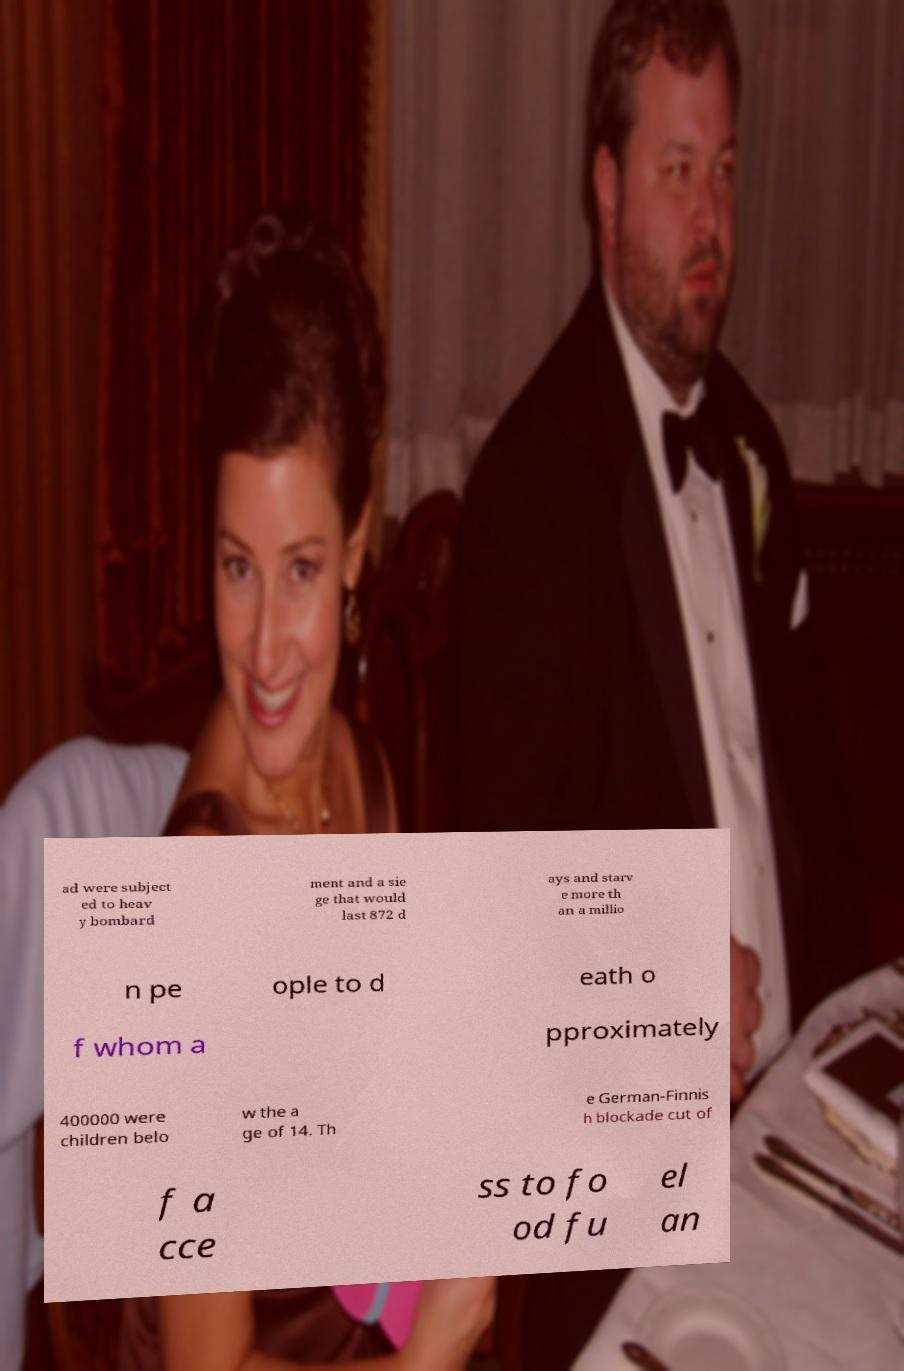For documentation purposes, I need the text within this image transcribed. Could you provide that? ad were subject ed to heav y bombard ment and a sie ge that would last 872 d ays and starv e more th an a millio n pe ople to d eath o f whom a pproximately 400000 were children belo w the a ge of 14. Th e German-Finnis h blockade cut of f a cce ss to fo od fu el an 